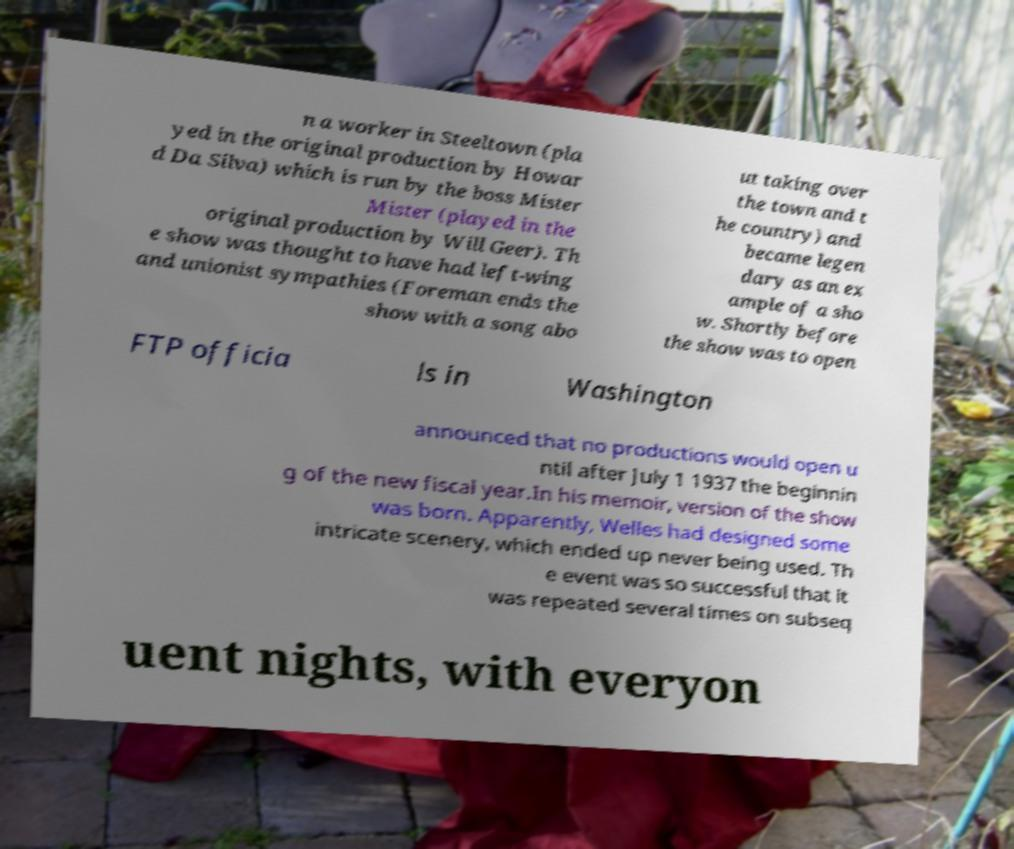Please identify and transcribe the text found in this image. n a worker in Steeltown (pla yed in the original production by Howar d Da Silva) which is run by the boss Mister Mister (played in the original production by Will Geer). Th e show was thought to have had left-wing and unionist sympathies (Foreman ends the show with a song abo ut taking over the town and t he country) and became legen dary as an ex ample of a sho w. Shortly before the show was to open FTP officia ls in Washington announced that no productions would open u ntil after July 1 1937 the beginnin g of the new fiscal year.In his memoir, version of the show was born. Apparently, Welles had designed some intricate scenery, which ended up never being used. Th e event was so successful that it was repeated several times on subseq uent nights, with everyon 